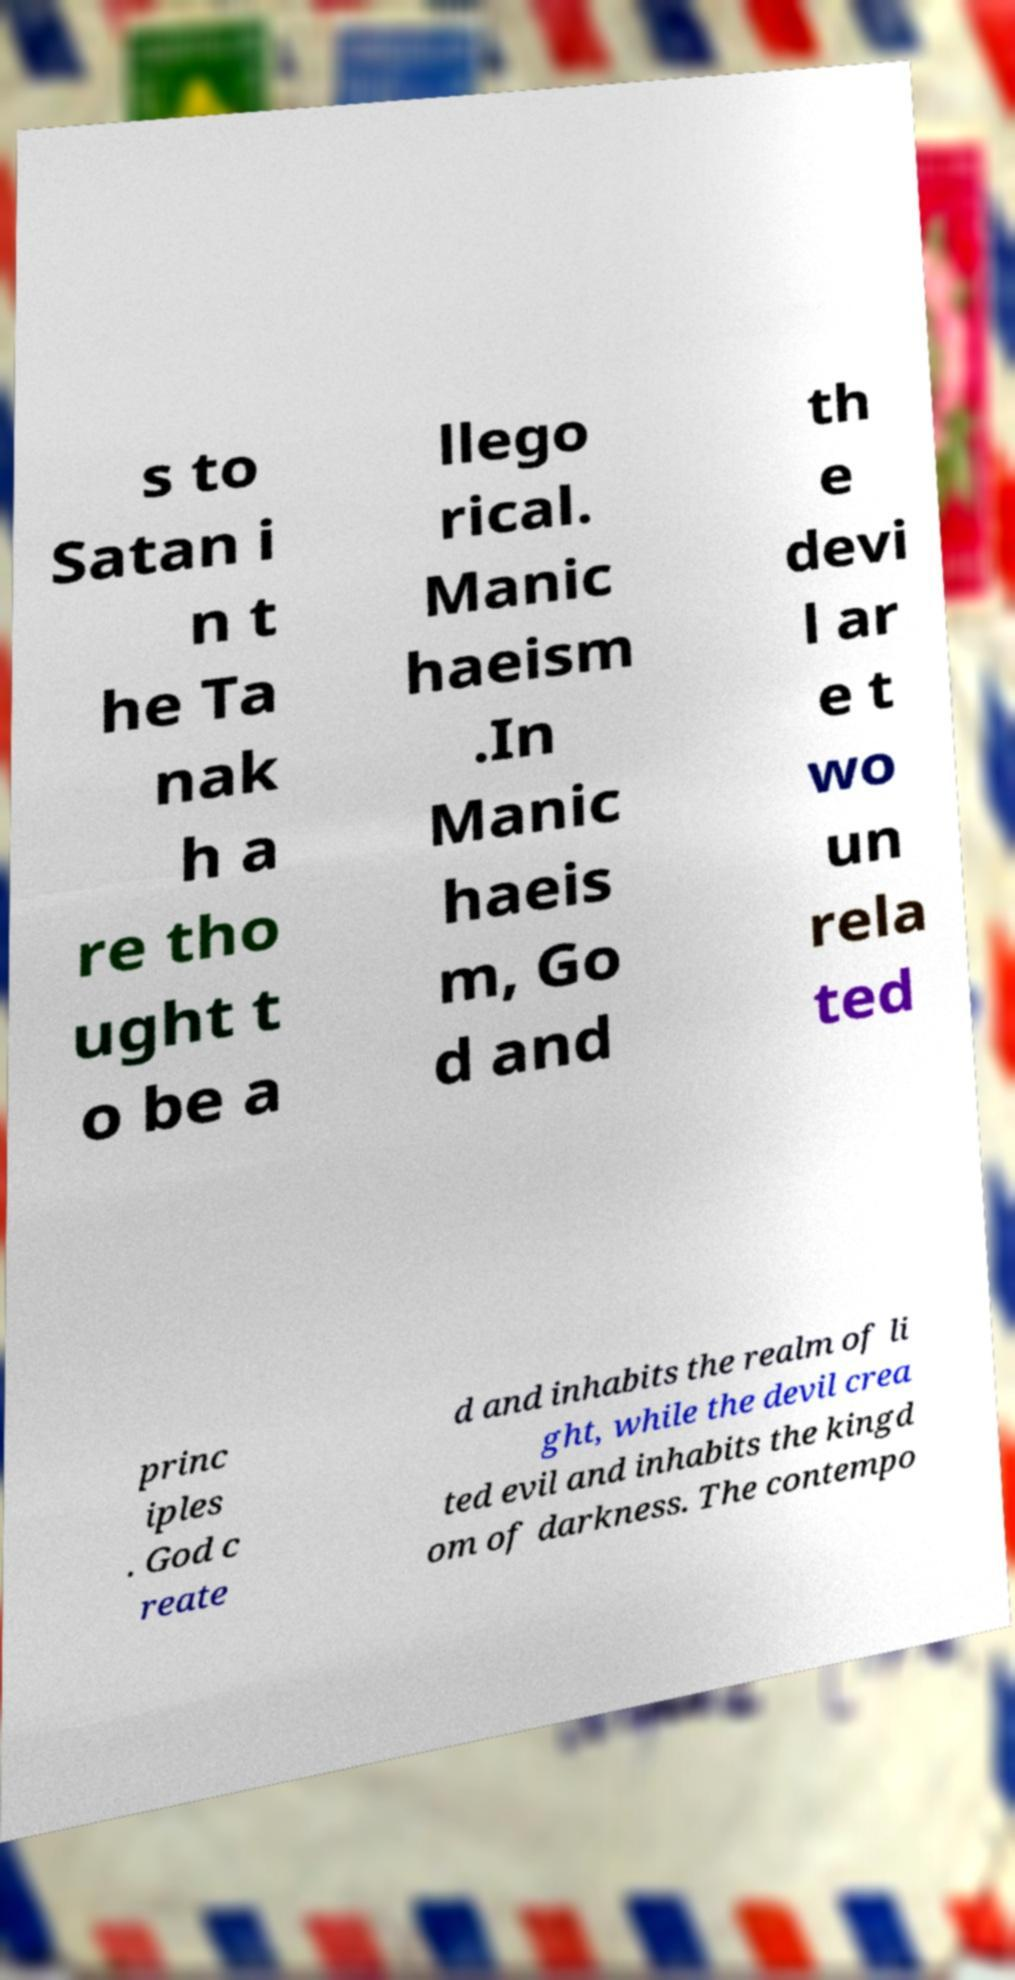Please read and relay the text visible in this image. What does it say? s to Satan i n t he Ta nak h a re tho ught t o be a llego rical. Manic haeism .In Manic haeis m, Go d and th e devi l ar e t wo un rela ted princ iples . God c reate d and inhabits the realm of li ght, while the devil crea ted evil and inhabits the kingd om of darkness. The contempo 